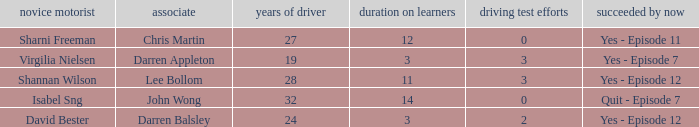What is the average number of years on learners of the drivers over the age of 24 with less than 0 attempts at the licence test? None. 